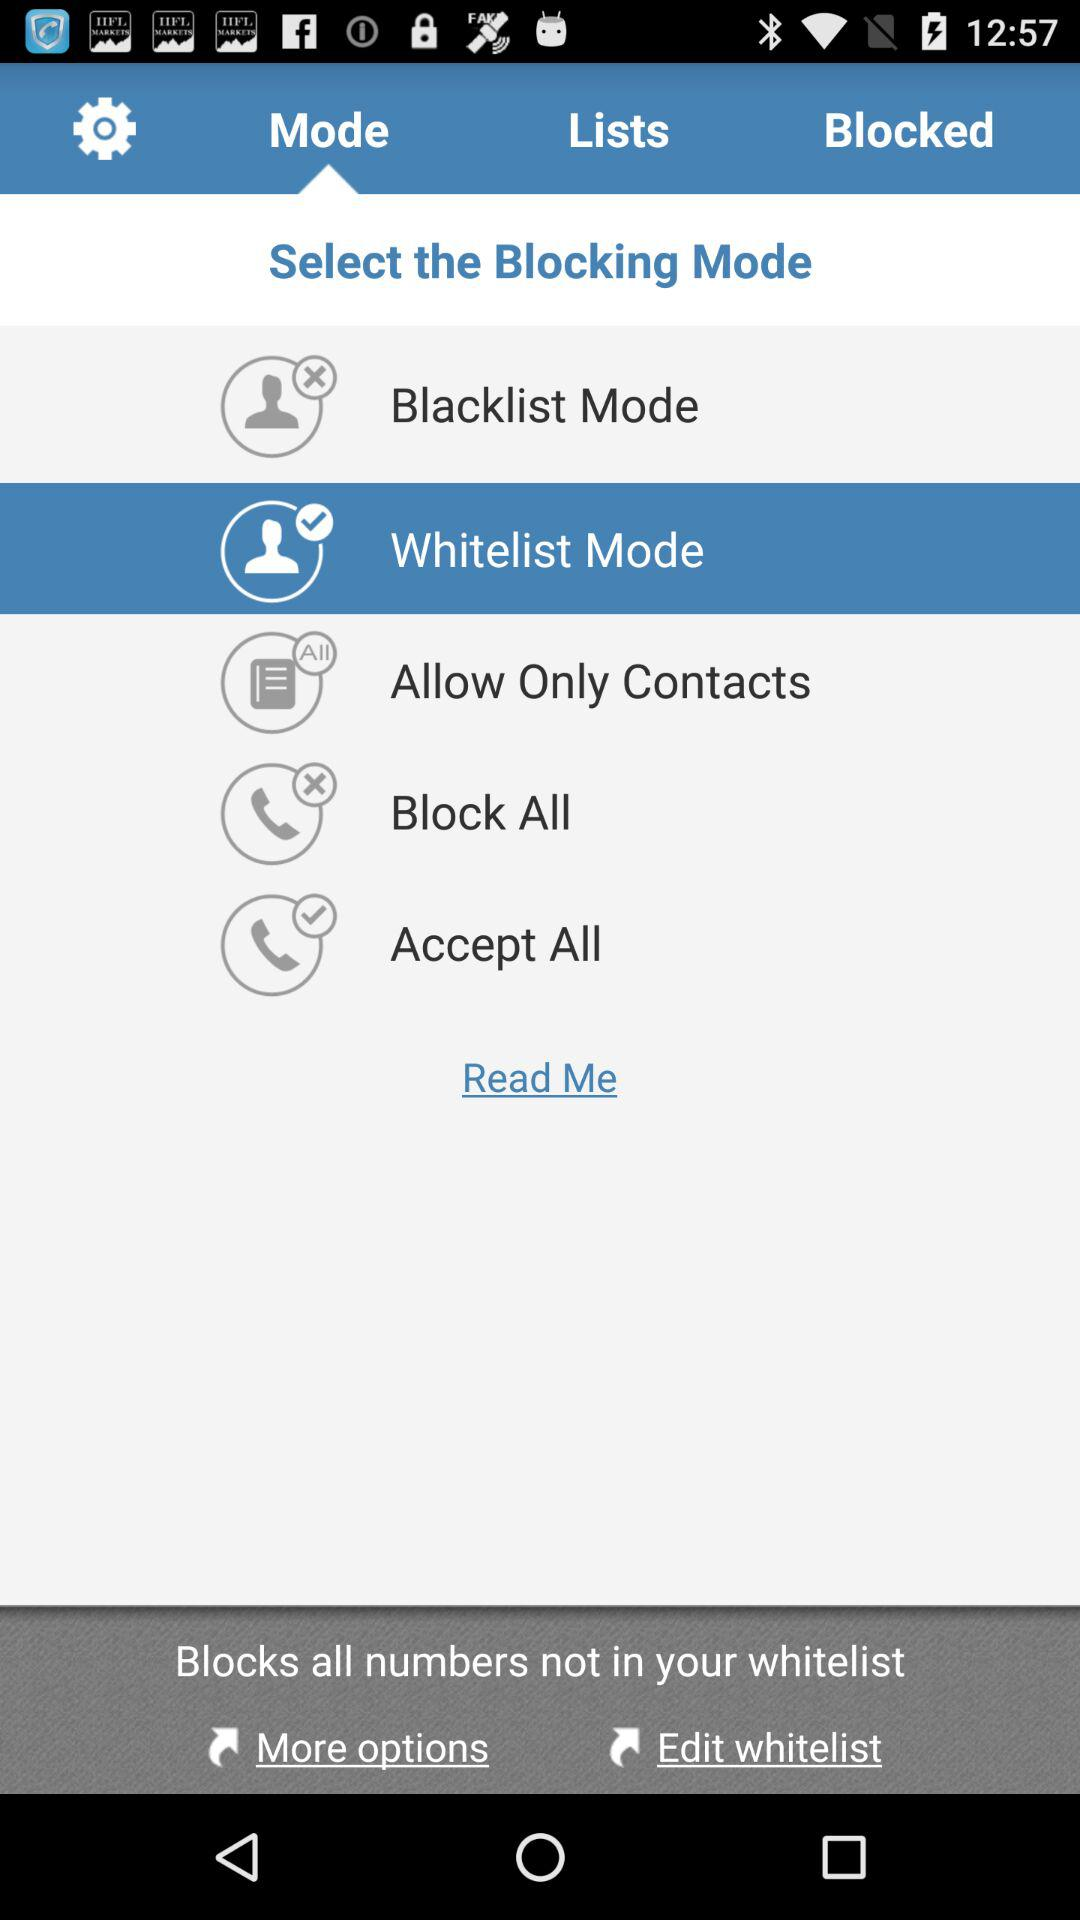Which blocking mode is selected? The selected blocking mode is "Whitelist Mode". 